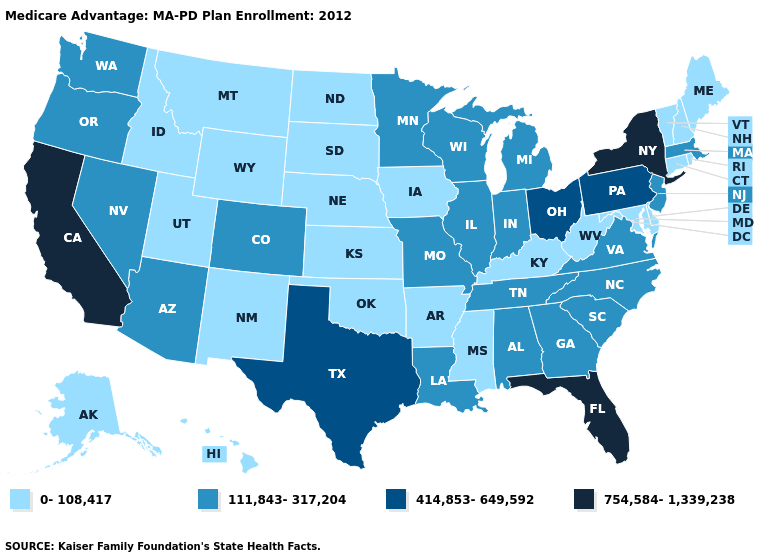Name the states that have a value in the range 111,843-317,204?
Be succinct. Alabama, Arizona, Colorado, Georgia, Illinois, Indiana, Louisiana, Massachusetts, Michigan, Minnesota, Missouri, North Carolina, New Jersey, Nevada, Oregon, South Carolina, Tennessee, Virginia, Washington, Wisconsin. Which states have the highest value in the USA?
Quick response, please. California, Florida, New York. Which states have the lowest value in the USA?
Keep it brief. Alaska, Arkansas, Connecticut, Delaware, Hawaii, Iowa, Idaho, Kansas, Kentucky, Maryland, Maine, Mississippi, Montana, North Dakota, Nebraska, New Hampshire, New Mexico, Oklahoma, Rhode Island, South Dakota, Utah, Vermont, West Virginia, Wyoming. What is the lowest value in states that border Washington?
Quick response, please. 0-108,417. Does South Dakota have the same value as Washington?
Answer briefly. No. Among the states that border California , which have the highest value?
Answer briefly. Arizona, Nevada, Oregon. What is the highest value in the USA?
Answer briefly. 754,584-1,339,238. What is the highest value in the MidWest ?
Give a very brief answer. 414,853-649,592. What is the lowest value in the USA?
Be succinct. 0-108,417. Does Florida have the highest value in the USA?
Quick response, please. Yes. Does California have the highest value in the USA?
Answer briefly. Yes. What is the lowest value in the MidWest?
Keep it brief. 0-108,417. Name the states that have a value in the range 754,584-1,339,238?
Concise answer only. California, Florida, New York. Which states have the lowest value in the West?
Write a very short answer. Alaska, Hawaii, Idaho, Montana, New Mexico, Utah, Wyoming. 